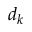<formula> <loc_0><loc_0><loc_500><loc_500>d _ { k }</formula> 